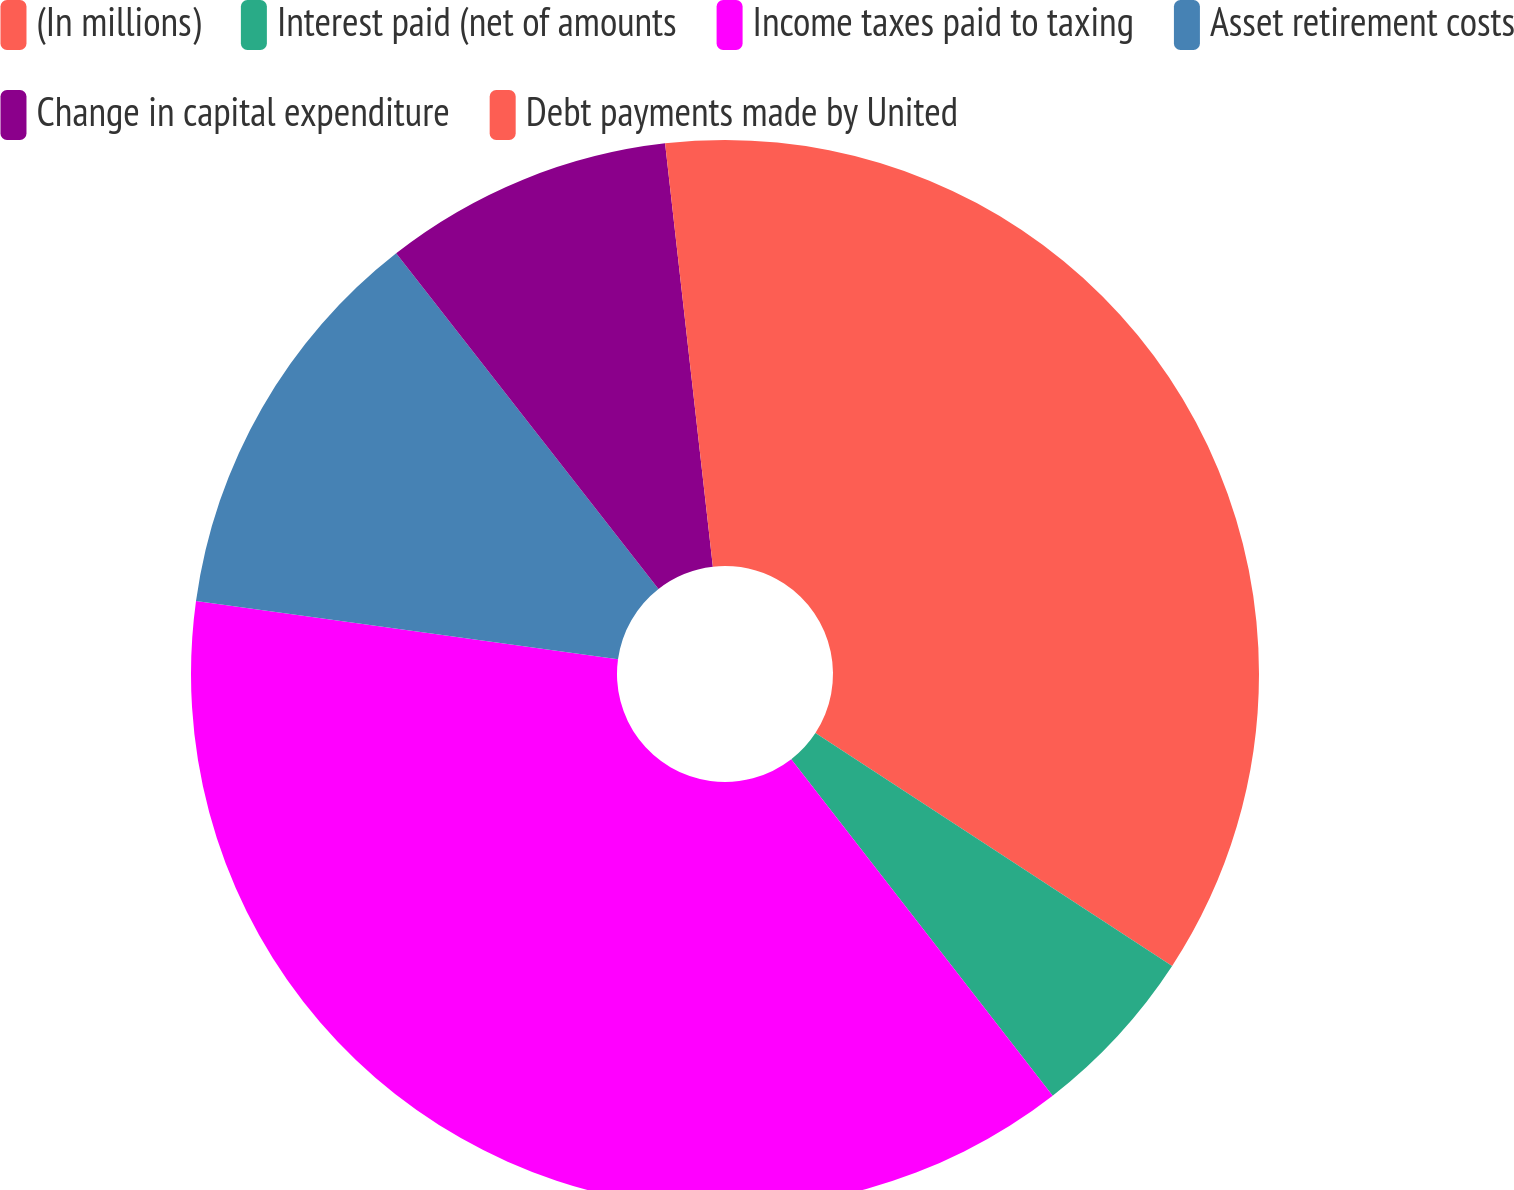<chart> <loc_0><loc_0><loc_500><loc_500><pie_chart><fcel>(In millions)<fcel>Interest paid (net of amounts<fcel>Income taxes paid to taxing<fcel>Asset retirement costs<fcel>Change in capital expenditure<fcel>Debt payments made by United<nl><fcel>34.21%<fcel>5.28%<fcel>37.7%<fcel>12.26%<fcel>8.77%<fcel>1.79%<nl></chart> 